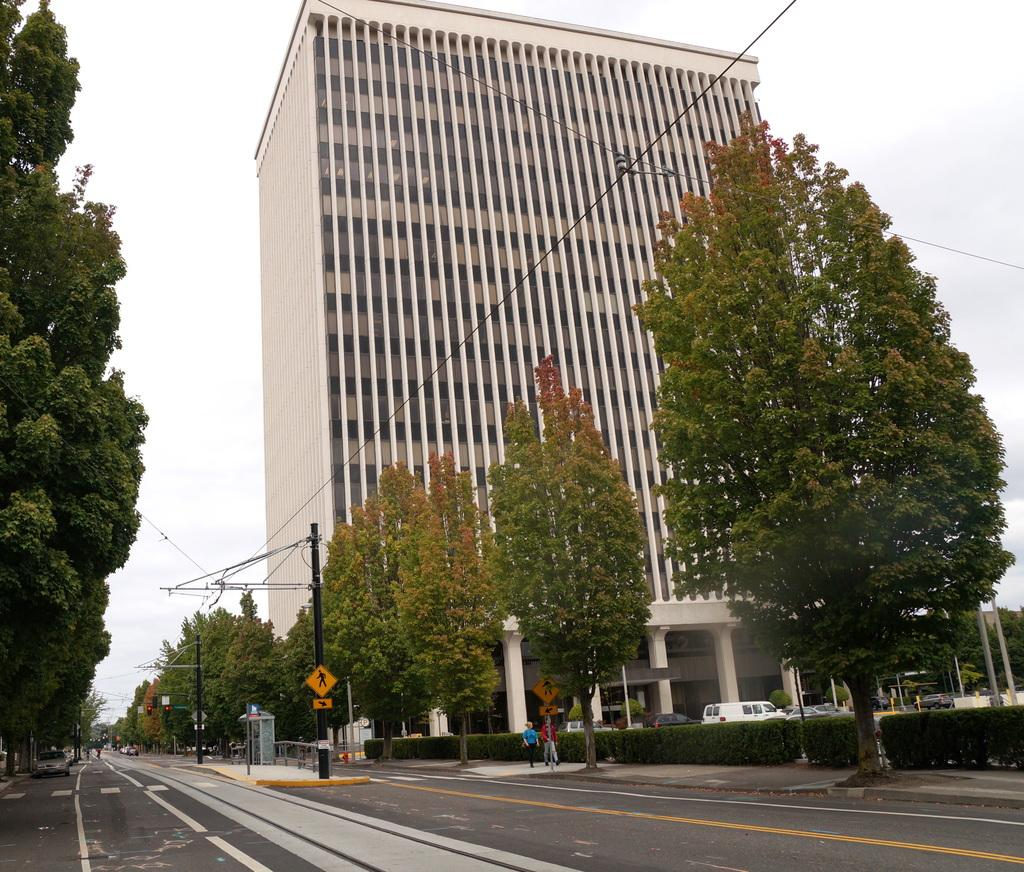What is the main subject of the image? The main subject of the image is a view of a road. What can be seen behind the road? There are trees behind the road. What is located behind the trees? There is a big building behind the trees. What is visible at the top of the image? The sky is visible at the top of the image. What type of cake is being delivered by the truck in the image? There is no truck or cake present in the image. 